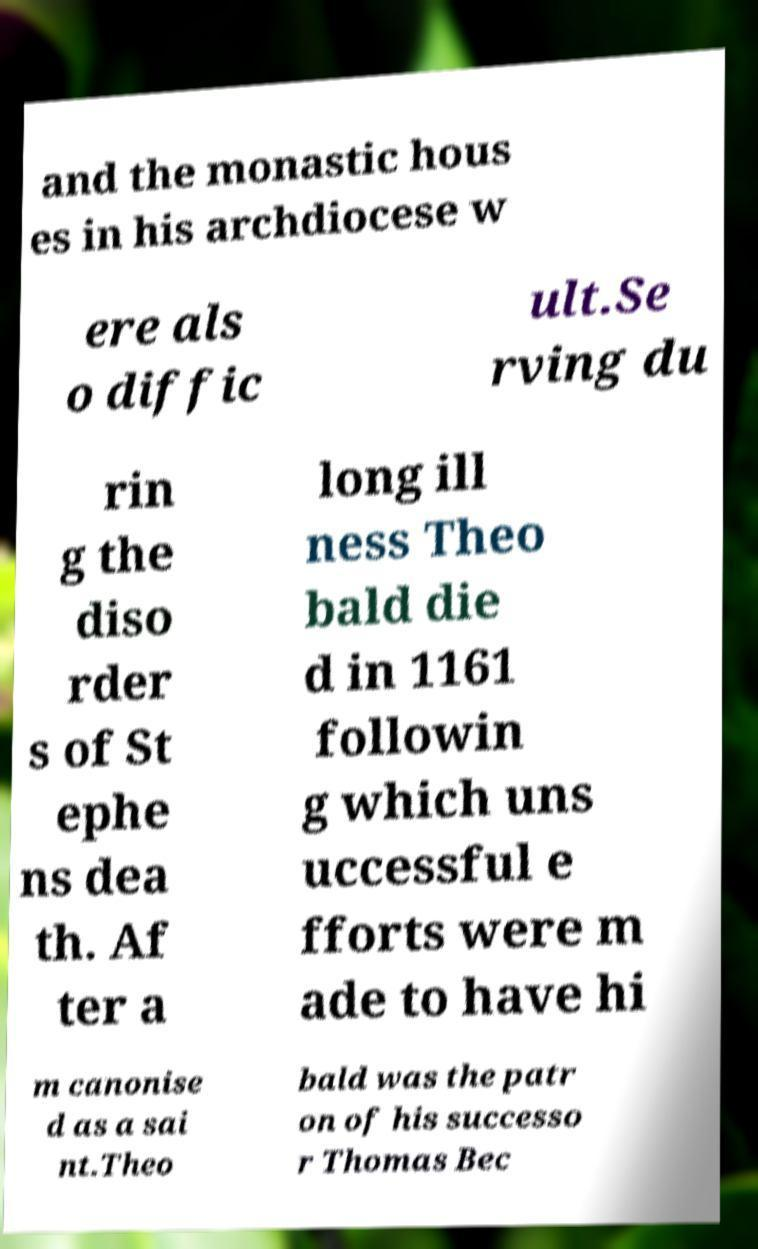Can you read and provide the text displayed in the image?This photo seems to have some interesting text. Can you extract and type it out for me? and the monastic hous es in his archdiocese w ere als o diffic ult.Se rving du rin g the diso rder s of St ephe ns dea th. Af ter a long ill ness Theo bald die d in 1161 followin g which uns uccessful e fforts were m ade to have hi m canonise d as a sai nt.Theo bald was the patr on of his successo r Thomas Bec 